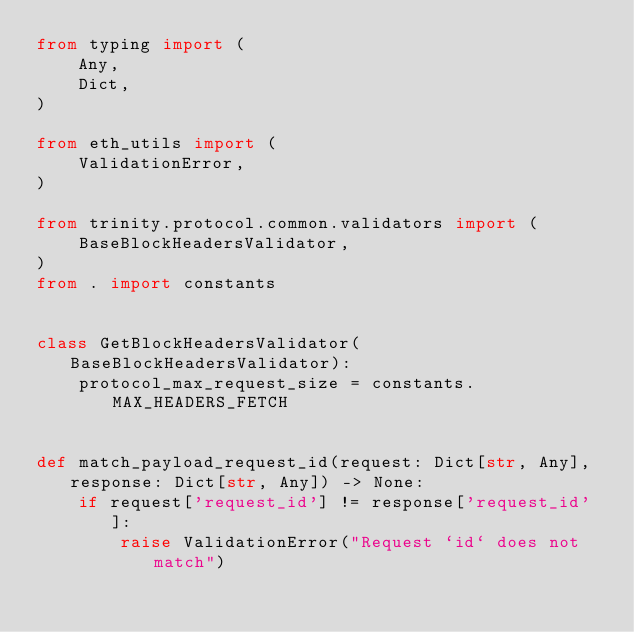Convert code to text. <code><loc_0><loc_0><loc_500><loc_500><_Python_>from typing import (
    Any,
    Dict,
)

from eth_utils import (
    ValidationError,
)

from trinity.protocol.common.validators import (
    BaseBlockHeadersValidator,
)
from . import constants


class GetBlockHeadersValidator(BaseBlockHeadersValidator):
    protocol_max_request_size = constants.MAX_HEADERS_FETCH


def match_payload_request_id(request: Dict[str, Any], response: Dict[str, Any]) -> None:
    if request['request_id'] != response['request_id']:
        raise ValidationError("Request `id` does not match")
</code> 